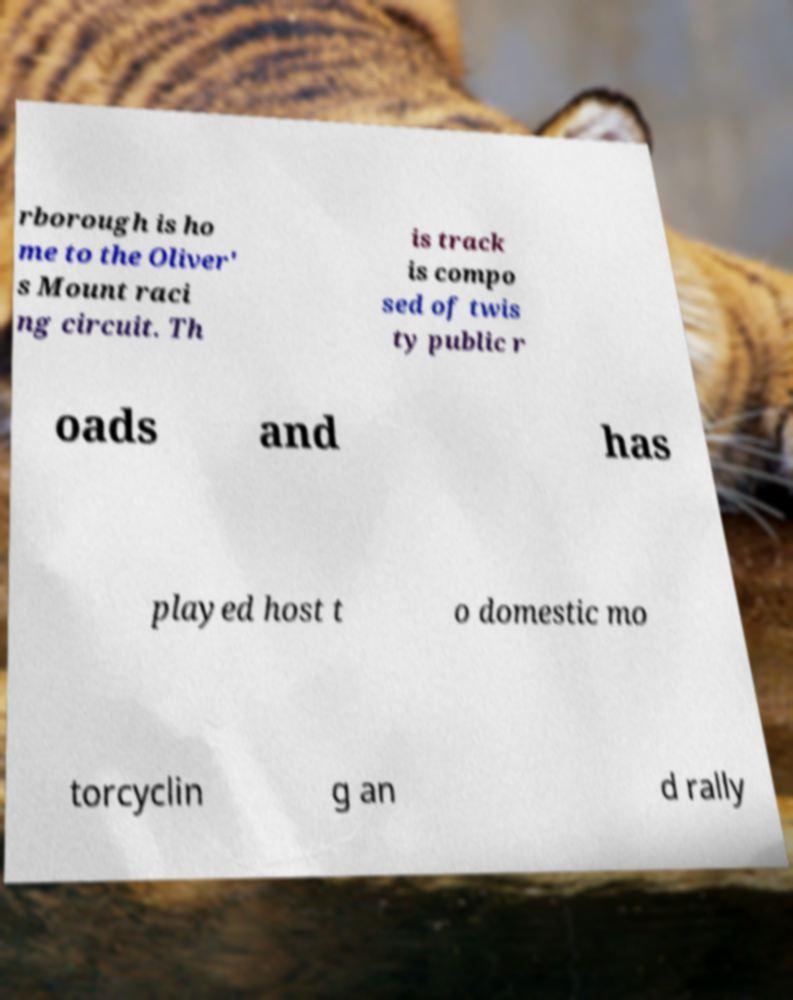Please read and relay the text visible in this image. What does it say? rborough is ho me to the Oliver' s Mount raci ng circuit. Th is track is compo sed of twis ty public r oads and has played host t o domestic mo torcyclin g an d rally 